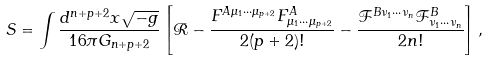Convert formula to latex. <formula><loc_0><loc_0><loc_500><loc_500>S = \int \frac { d ^ { n + p + 2 } x \sqrt { - g } } { 1 6 \pi G _ { n + p + 2 } } \left [ \mathcal { R } - \frac { F ^ { A \mu _ { 1 } \cdots \mu _ { p + 2 } } F ^ { A } _ { \mu _ { 1 } \cdots \mu _ { p + 2 } } } { 2 ( p + 2 ) ! } - \frac { \mathcal { F } ^ { B \nu _ { 1 } \cdots \nu _ { n } } \mathcal { F } ^ { B } _ { \nu _ { 1 } \cdots \nu _ { n } } } { 2 n ! } \right ] ,</formula> 